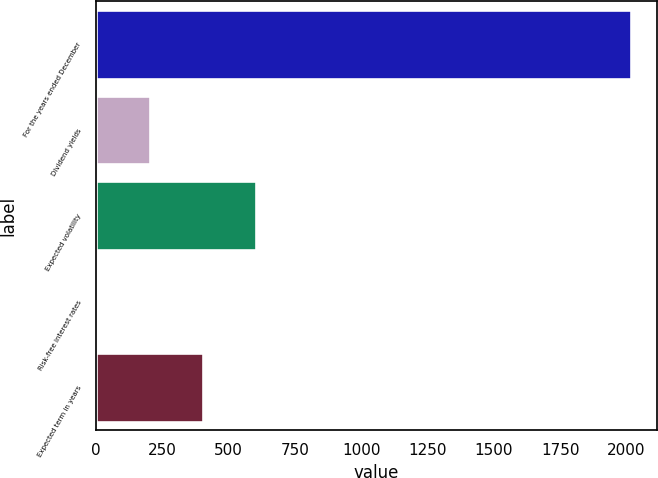Convert chart. <chart><loc_0><loc_0><loc_500><loc_500><bar_chart><fcel>For the years ended December<fcel>Dividend yields<fcel>Expected volatility<fcel>Risk-free interest rates<fcel>Expected term in years<nl><fcel>2016<fcel>202.95<fcel>605.85<fcel>1.5<fcel>404.4<nl></chart> 